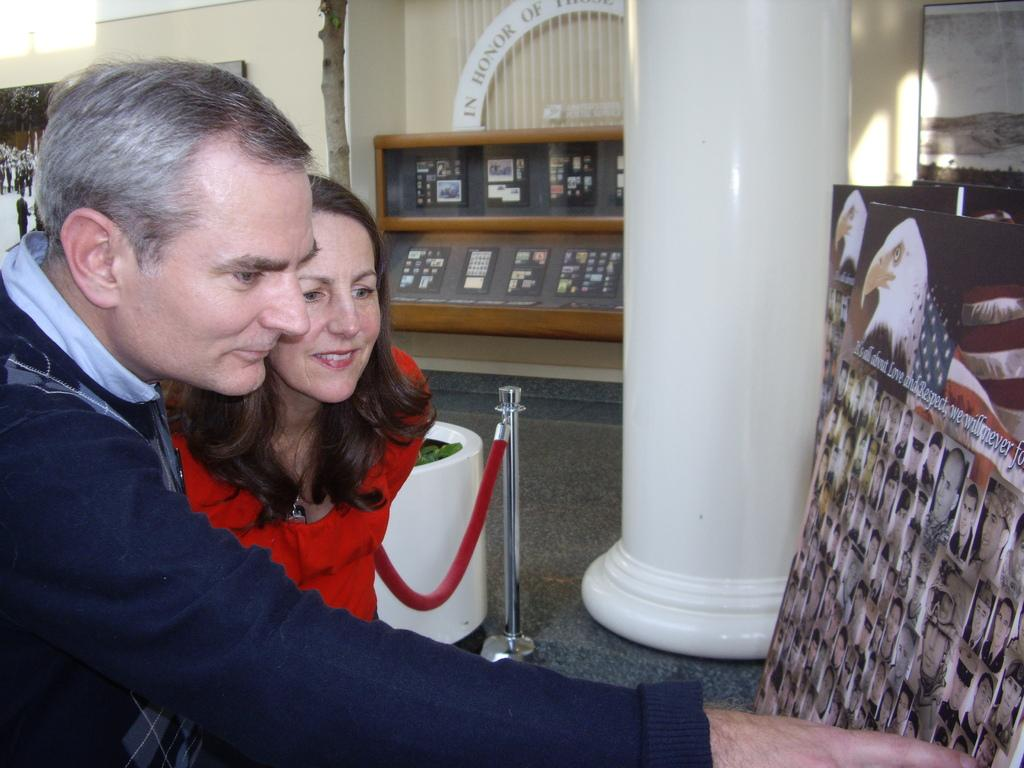Who are the people in the image? There is a man and a woman in the image. Where are the man and woman located in the image? The man and woman are standing at the left side of the image. What are the man and woman looking at in the image? The man and woman are looking at a poster in the image. What can be seen in the background of the image? There is a white color pillar in the image. What type of key is the man holding in the image? There is no key present in the image. 